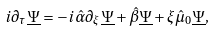Convert formula to latex. <formula><loc_0><loc_0><loc_500><loc_500>i \partial _ { \tau } \underline { \Psi } = - i \hat { \alpha } \partial _ { \xi } \underline { \Psi } + \hat { \beta } \underline { \Psi } + \xi \hat { \mu } _ { 0 } \underline { \Psi } ,</formula> 